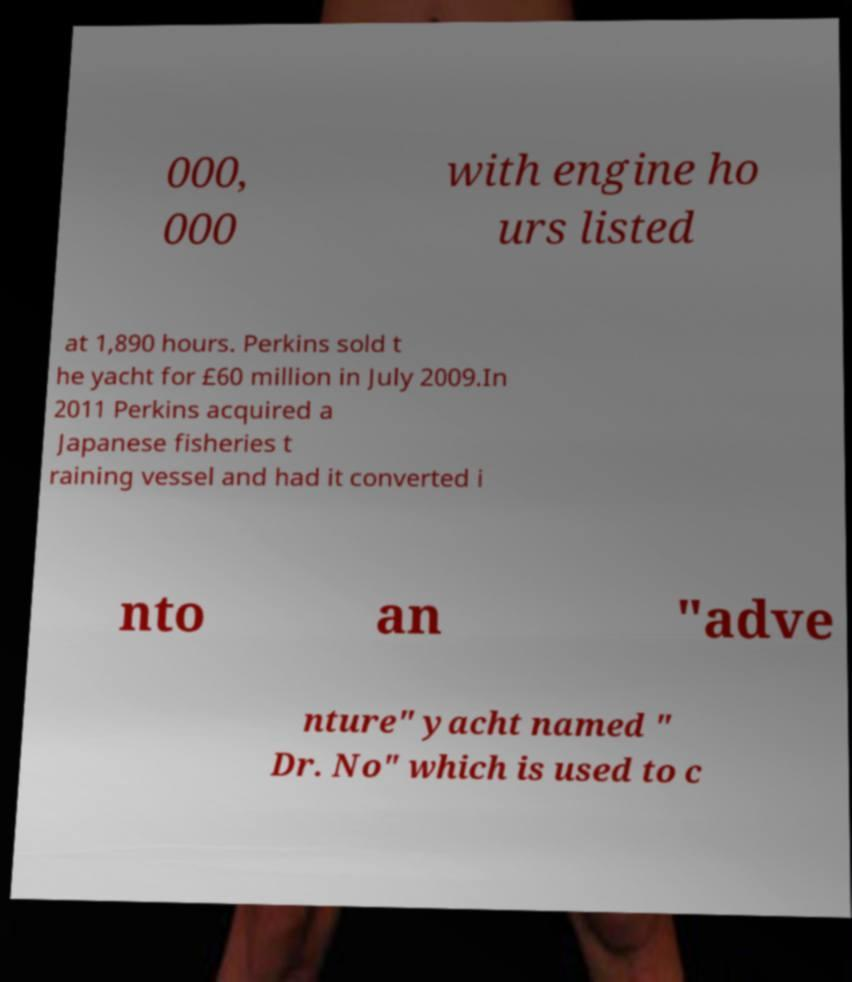Please read and relay the text visible in this image. What does it say? 000, 000 with engine ho urs listed at 1,890 hours. Perkins sold t he yacht for £60 million in July 2009.In 2011 Perkins acquired a Japanese fisheries t raining vessel and had it converted i nto an "adve nture" yacht named " Dr. No" which is used to c 